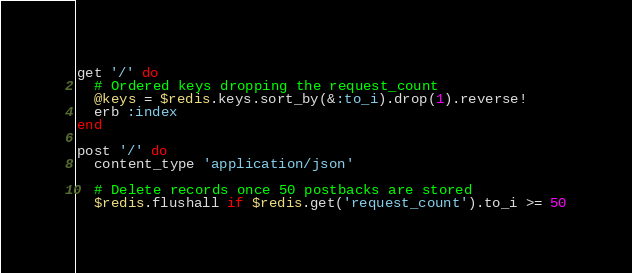Convert code to text. <code><loc_0><loc_0><loc_500><loc_500><_Ruby_>
get '/' do
  # Ordered keys dropping the request_count
  @keys = $redis.keys.sort_by(&:to_i).drop(1).reverse!
  erb :index
end

post '/' do
  content_type 'application/json'

  # Delete records once 50 postbacks are stored
  $redis.flushall if $redis.get('request_count').to_i >= 50
</code> 